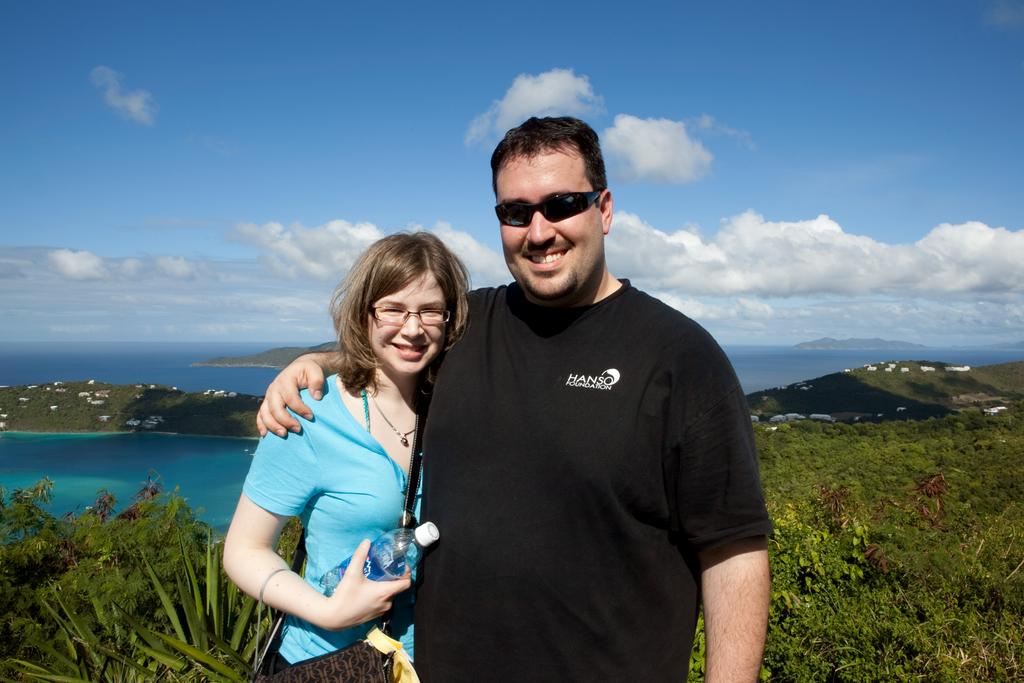How many people are present in the image? There is a woman and a man present in the image. What is the natural environment visible in the image? Grass, water, and trees are visible in the background of the image. What is the condition of the sky in the image? The sky is visible in the background of the image, and there are clouds present. What type of butter is being used in the class depicted in the image? There is no class or butter present in the image; it features a woman and a man in a natural environment. 